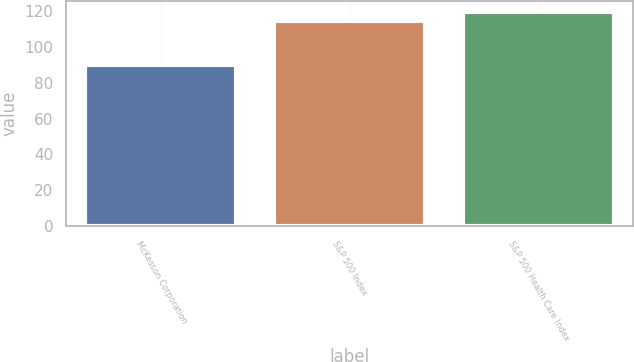<chart> <loc_0><loc_0><loc_500><loc_500><bar_chart><fcel>McKesson Corporation<fcel>S&P 500 Index<fcel>S&P 500 Health Care Index<nl><fcel>89.99<fcel>114.74<fcel>119.65<nl></chart> 